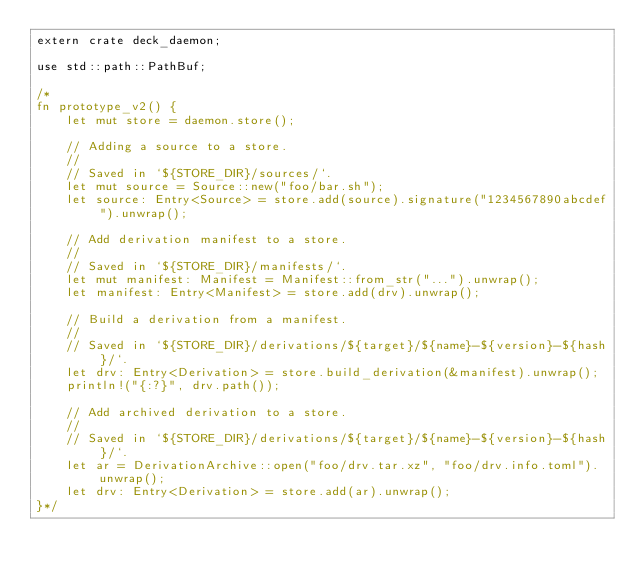<code> <loc_0><loc_0><loc_500><loc_500><_Rust_>extern crate deck_daemon;

use std::path::PathBuf;

/*
fn prototype_v2() {
    let mut store = daemon.store();

    // Adding a source to a store.
    //
    // Saved in `${STORE_DIR}/sources/`.
    let mut source = Source::new("foo/bar.sh");
    let source: Entry<Source> = store.add(source).signature("1234567890abcdef").unwrap();

    // Add derivation manifest to a store.
    //
    // Saved in `${STORE_DIR}/manifests/`.
    let mut manifest: Manifest = Manifest::from_str("...").unwrap();
    let manifest: Entry<Manifest> = store.add(drv).unwrap();

    // Build a derivation from a manifest.
    //
    // Saved in `${STORE_DIR}/derivations/${target}/${name}-${version}-${hash}/`.
    let drv: Entry<Derivation> = store.build_derivation(&manifest).unwrap();
    println!("{:?}", drv.path());

    // Add archived derivation to a store.
    //
    // Saved in `${STORE_DIR}/derivations/${target}/${name}-${version}-${hash}/`.
    let ar = DerivationArchive::open("foo/drv.tar.xz", "foo/drv.info.toml").unwrap();
    let drv: Entry<Derivation> = store.add(ar).unwrap();
}*/
</code> 